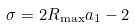<formula> <loc_0><loc_0><loc_500><loc_500>\sigma = 2 R _ { \max } a _ { 1 } - 2</formula> 